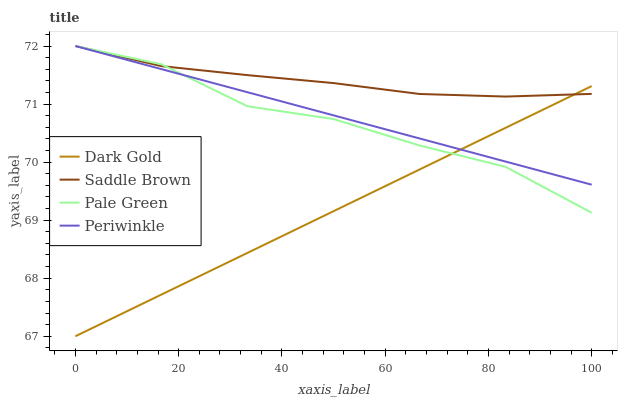Does Dark Gold have the minimum area under the curve?
Answer yes or no. Yes. Does Saddle Brown have the maximum area under the curve?
Answer yes or no. Yes. Does Periwinkle have the minimum area under the curve?
Answer yes or no. No. Does Periwinkle have the maximum area under the curve?
Answer yes or no. No. Is Periwinkle the smoothest?
Answer yes or no. Yes. Is Pale Green the roughest?
Answer yes or no. Yes. Is Saddle Brown the smoothest?
Answer yes or no. No. Is Saddle Brown the roughest?
Answer yes or no. No. Does Dark Gold have the lowest value?
Answer yes or no. Yes. Does Periwinkle have the lowest value?
Answer yes or no. No. Does Saddle Brown have the highest value?
Answer yes or no. Yes. Does Dark Gold have the highest value?
Answer yes or no. No. Does Pale Green intersect Saddle Brown?
Answer yes or no. Yes. Is Pale Green less than Saddle Brown?
Answer yes or no. No. Is Pale Green greater than Saddle Brown?
Answer yes or no. No. 